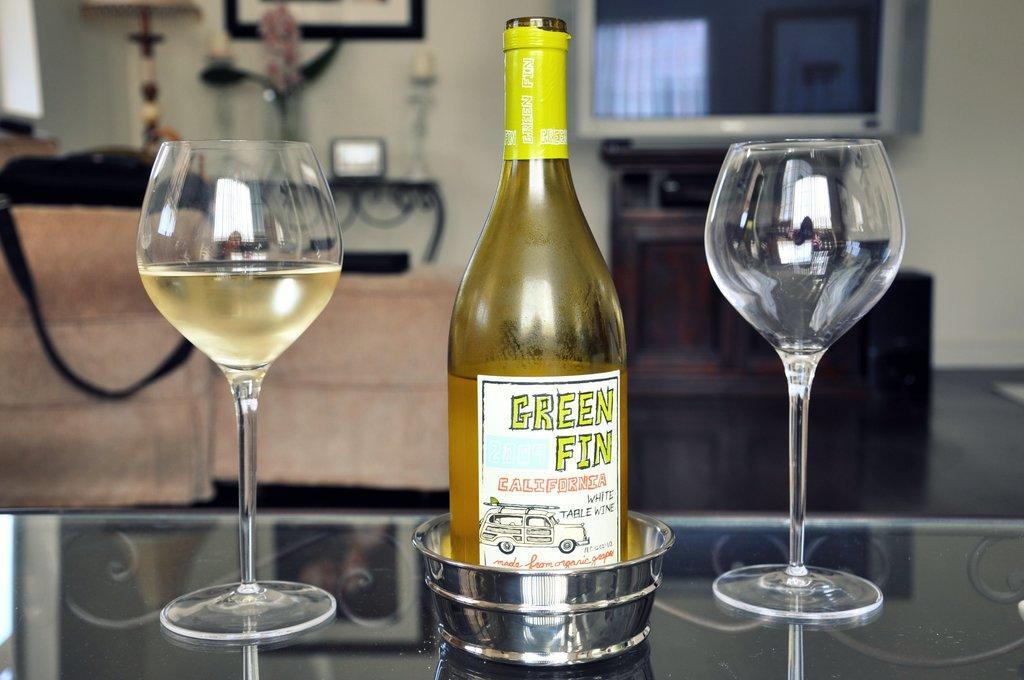In one or two sentences, can you explain what this image depicts? This image is clicked inside a room. There is a table in the bottom that is a glass one. There is a bottle in the middle of the image. and 2 glasses are placed. One is filled with some drink. On the left side there is a bag on the table. And on the top right corner there is a window. 